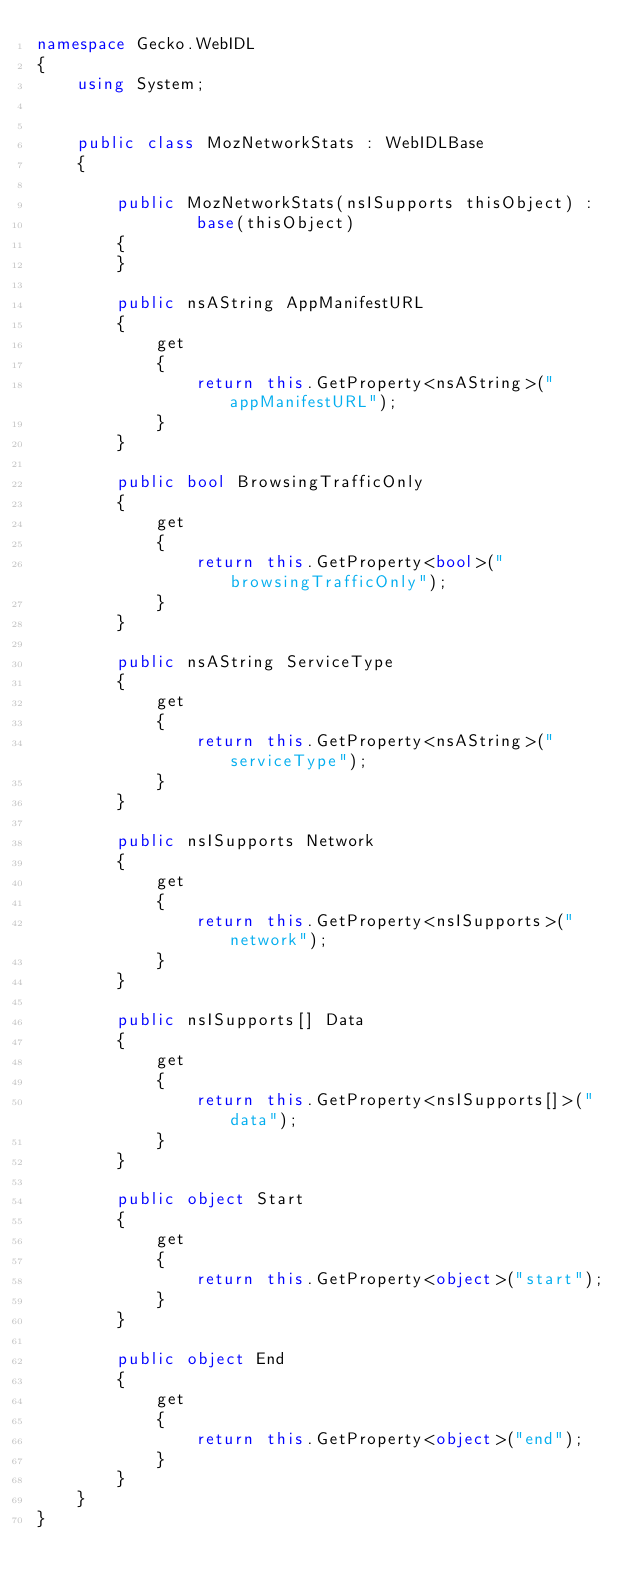Convert code to text. <code><loc_0><loc_0><loc_500><loc_500><_C#_>namespace Gecko.WebIDL
{
    using System;
    
    
    public class MozNetworkStats : WebIDLBase
    {
        
        public MozNetworkStats(nsISupports thisObject) : 
                base(thisObject)
        {
        }
        
        public nsAString AppManifestURL
        {
            get
            {
                return this.GetProperty<nsAString>("appManifestURL");
            }
        }
        
        public bool BrowsingTrafficOnly
        {
            get
            {
                return this.GetProperty<bool>("browsingTrafficOnly");
            }
        }
        
        public nsAString ServiceType
        {
            get
            {
                return this.GetProperty<nsAString>("serviceType");
            }
        }
        
        public nsISupports Network
        {
            get
            {
                return this.GetProperty<nsISupports>("network");
            }
        }
        
        public nsISupports[] Data
        {
            get
            {
                return this.GetProperty<nsISupports[]>("data");
            }
        }
        
        public object Start
        {
            get
            {
                return this.GetProperty<object>("start");
            }
        }
        
        public object End
        {
            get
            {
                return this.GetProperty<object>("end");
            }
        }
    }
}
</code> 